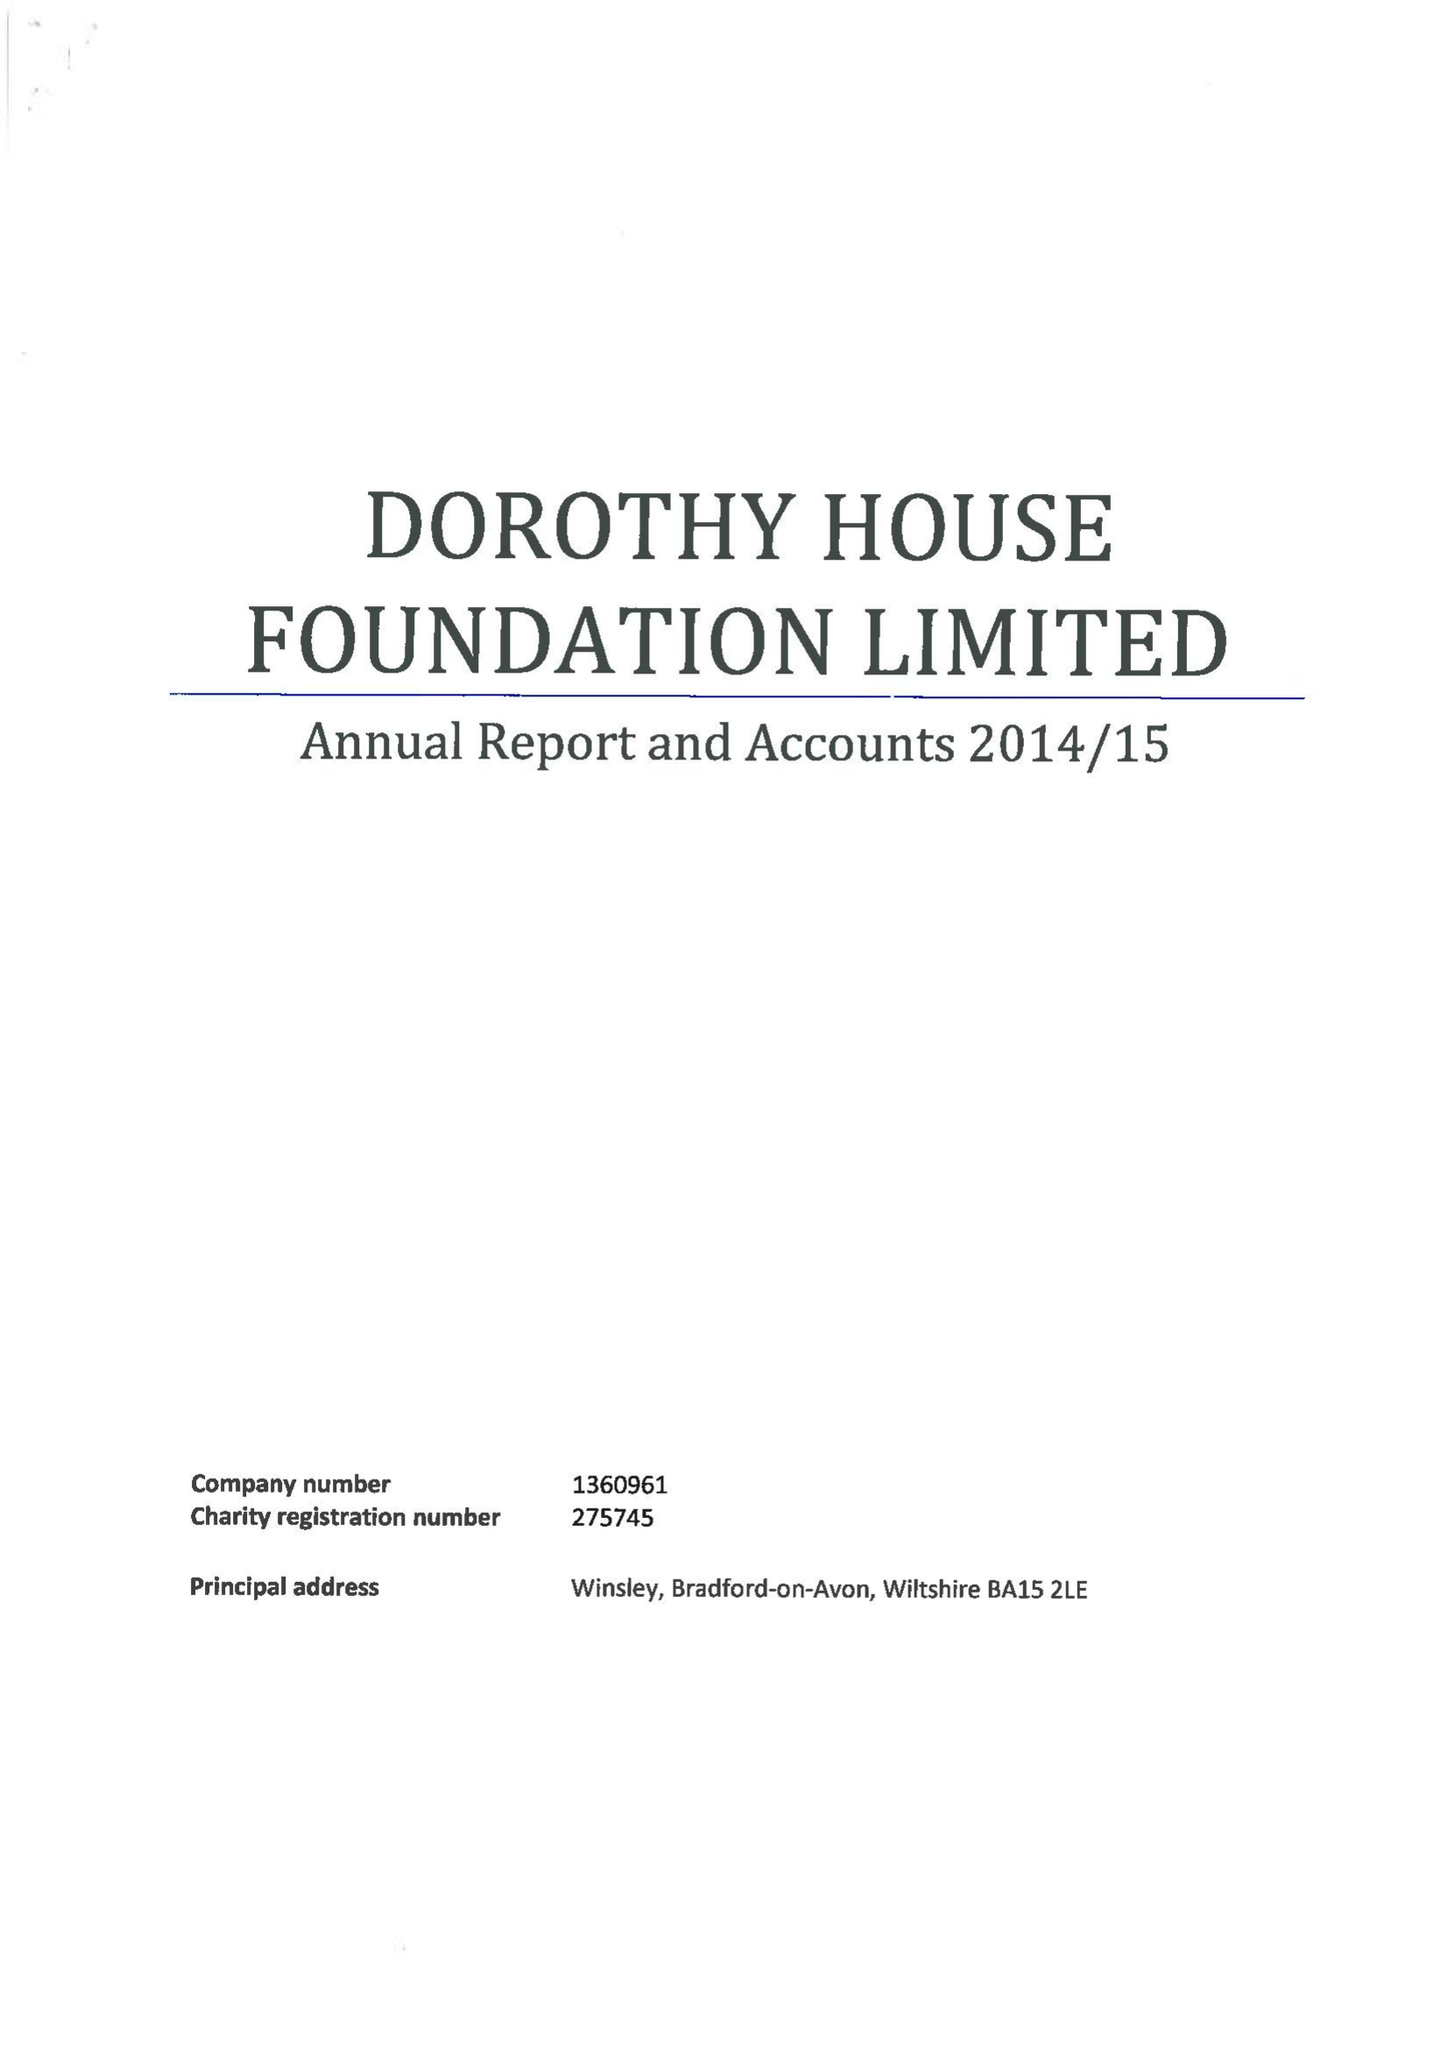What is the value for the report_date?
Answer the question using a single word or phrase. 2015-03-31 